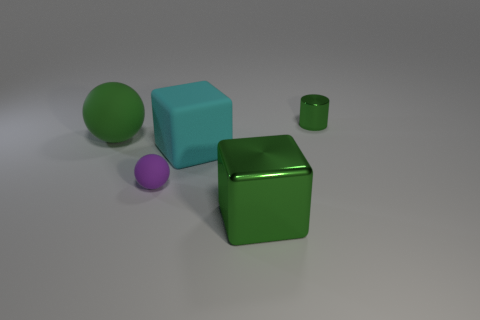Add 1 tiny matte cubes. How many objects exist? 6 Add 5 big green metallic objects. How many big green metallic objects exist? 6 Subtract 0 brown balls. How many objects are left? 5 Subtract all spheres. How many objects are left? 3 Subtract all brown shiny cylinders. Subtract all large matte objects. How many objects are left? 3 Add 1 tiny things. How many tiny things are left? 3 